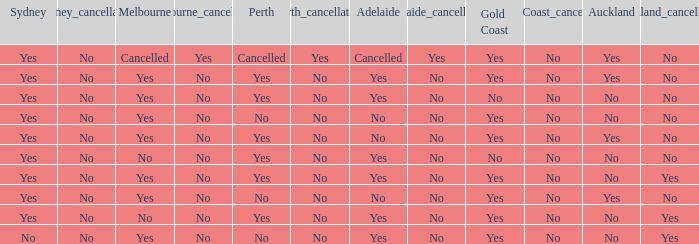What is The Melbourne with a No- Gold Coast Yes, No. 